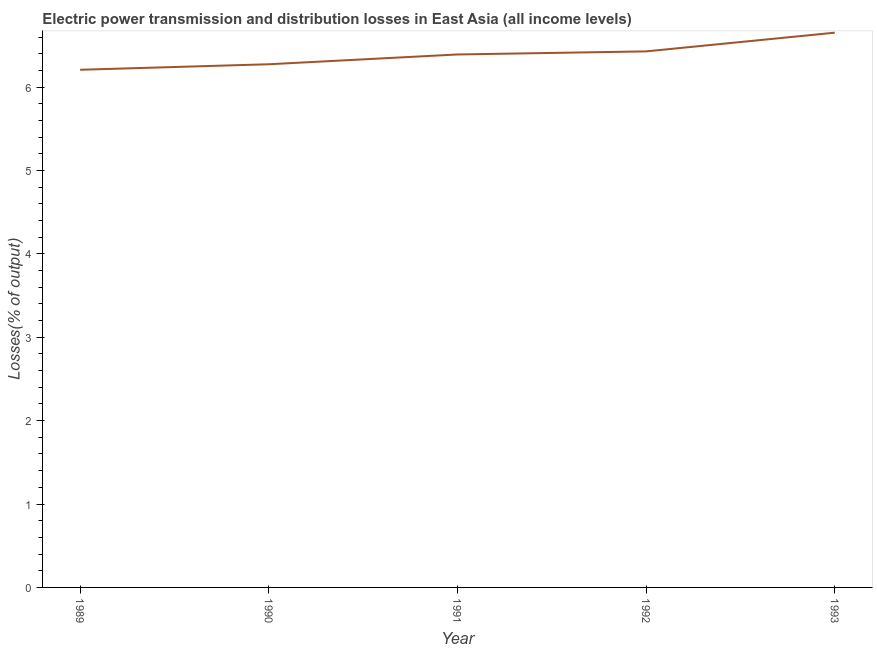What is the electric power transmission and distribution losses in 1992?
Your response must be concise. 6.43. Across all years, what is the maximum electric power transmission and distribution losses?
Provide a short and direct response. 6.65. Across all years, what is the minimum electric power transmission and distribution losses?
Keep it short and to the point. 6.21. In which year was the electric power transmission and distribution losses maximum?
Your answer should be very brief. 1993. What is the sum of the electric power transmission and distribution losses?
Offer a very short reply. 31.95. What is the difference between the electric power transmission and distribution losses in 1989 and 1992?
Provide a short and direct response. -0.22. What is the average electric power transmission and distribution losses per year?
Offer a very short reply. 6.39. What is the median electric power transmission and distribution losses?
Provide a succinct answer. 6.39. In how many years, is the electric power transmission and distribution losses greater than 2 %?
Provide a succinct answer. 5. Do a majority of the years between 1990 and 1993 (inclusive) have electric power transmission and distribution losses greater than 2.6 %?
Offer a terse response. Yes. What is the ratio of the electric power transmission and distribution losses in 1989 to that in 1993?
Keep it short and to the point. 0.93. What is the difference between the highest and the second highest electric power transmission and distribution losses?
Offer a terse response. 0.22. Is the sum of the electric power transmission and distribution losses in 1991 and 1993 greater than the maximum electric power transmission and distribution losses across all years?
Provide a short and direct response. Yes. What is the difference between the highest and the lowest electric power transmission and distribution losses?
Your answer should be very brief. 0.44. In how many years, is the electric power transmission and distribution losses greater than the average electric power transmission and distribution losses taken over all years?
Keep it short and to the point. 3. How many years are there in the graph?
Your answer should be compact. 5. Does the graph contain grids?
Your response must be concise. No. What is the title of the graph?
Keep it short and to the point. Electric power transmission and distribution losses in East Asia (all income levels). What is the label or title of the Y-axis?
Your answer should be very brief. Losses(% of output). What is the Losses(% of output) in 1989?
Give a very brief answer. 6.21. What is the Losses(% of output) in 1990?
Your answer should be very brief. 6.27. What is the Losses(% of output) in 1991?
Your answer should be compact. 6.39. What is the Losses(% of output) of 1992?
Provide a short and direct response. 6.43. What is the Losses(% of output) of 1993?
Give a very brief answer. 6.65. What is the difference between the Losses(% of output) in 1989 and 1990?
Your response must be concise. -0.07. What is the difference between the Losses(% of output) in 1989 and 1991?
Provide a succinct answer. -0.18. What is the difference between the Losses(% of output) in 1989 and 1992?
Keep it short and to the point. -0.22. What is the difference between the Losses(% of output) in 1989 and 1993?
Offer a terse response. -0.44. What is the difference between the Losses(% of output) in 1990 and 1991?
Offer a very short reply. -0.12. What is the difference between the Losses(% of output) in 1990 and 1992?
Your answer should be compact. -0.15. What is the difference between the Losses(% of output) in 1990 and 1993?
Provide a short and direct response. -0.38. What is the difference between the Losses(% of output) in 1991 and 1992?
Offer a very short reply. -0.04. What is the difference between the Losses(% of output) in 1991 and 1993?
Offer a very short reply. -0.26. What is the difference between the Losses(% of output) in 1992 and 1993?
Offer a very short reply. -0.22. What is the ratio of the Losses(% of output) in 1989 to that in 1993?
Keep it short and to the point. 0.93. What is the ratio of the Losses(% of output) in 1990 to that in 1993?
Offer a very short reply. 0.94. What is the ratio of the Losses(% of output) in 1991 to that in 1992?
Give a very brief answer. 0.99. 